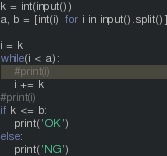Convert code to text. <code><loc_0><loc_0><loc_500><loc_500><_Python_>k = int(input())
a, b = [int(i) for i in input().split()]

i = k
while(i < a):
    #print(i)
    i += k
#print(i)
if k <= b:
    print('OK')
else:
    print('NG')</code> 